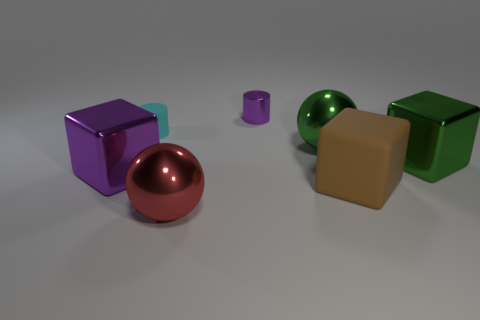What is the size of the matte object behind the large green thing that is in front of the green shiny thing left of the large green cube?
Give a very brief answer. Small. Is the number of large purple metal cubes that are behind the tiny purple metal object the same as the number of metal cubes?
Your answer should be very brief. No. There is a small metal object; is it the same shape as the small thing that is on the left side of the small purple metallic cylinder?
Your response must be concise. Yes. The other thing that is the same shape as the cyan thing is what size?
Give a very brief answer. Small. How many other objects are there of the same material as the big purple cube?
Your answer should be very brief. 4. What material is the big green sphere?
Your response must be concise. Metal. Does the matte object that is on the right side of the red metallic ball have the same color as the cube that is on the right side of the large brown rubber object?
Give a very brief answer. No. Is the number of tiny purple cylinders that are to the right of the big green shiny sphere greater than the number of big green metallic cubes?
Provide a short and direct response. No. What number of other things are the same color as the tiny matte thing?
Offer a terse response. 0. There is a purple shiny thing that is behind the green metal cube; does it have the same size as the tiny matte cylinder?
Your response must be concise. Yes. 